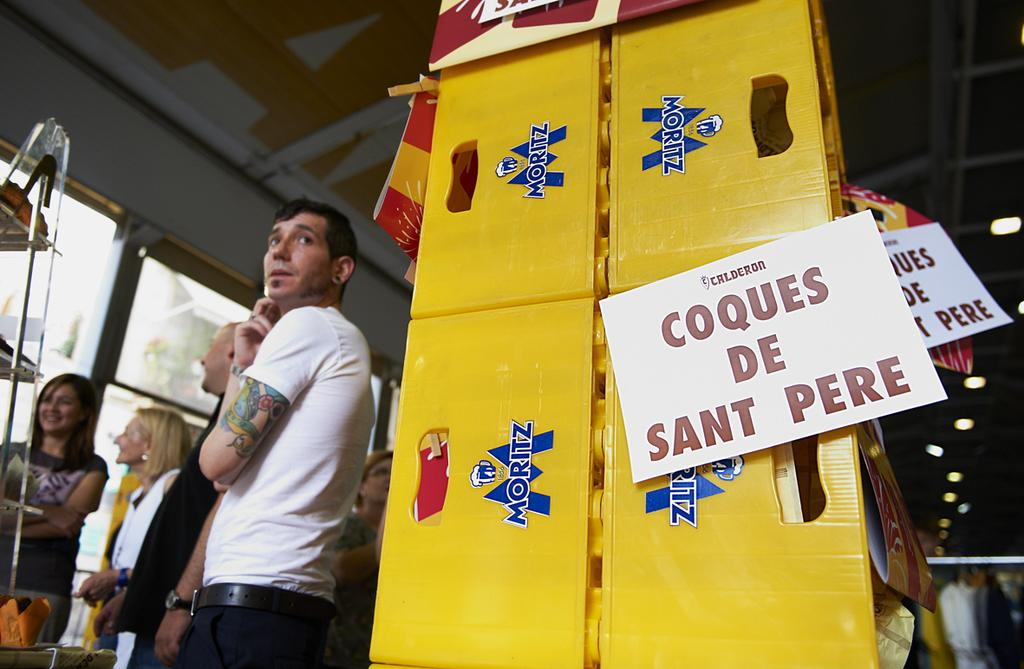What is the main object in the image? There is a big board in the image. What is attached to the board? Papers are stuck on the board. What can be seen behind the people in the image? There are people standing in front of a glass stand. What type of wing is visible on the board in the image? There is no wing visible on the board in the image. What kind of wood is used to make the board in the image? The type of wood used to make the board cannot be determined from the image. 